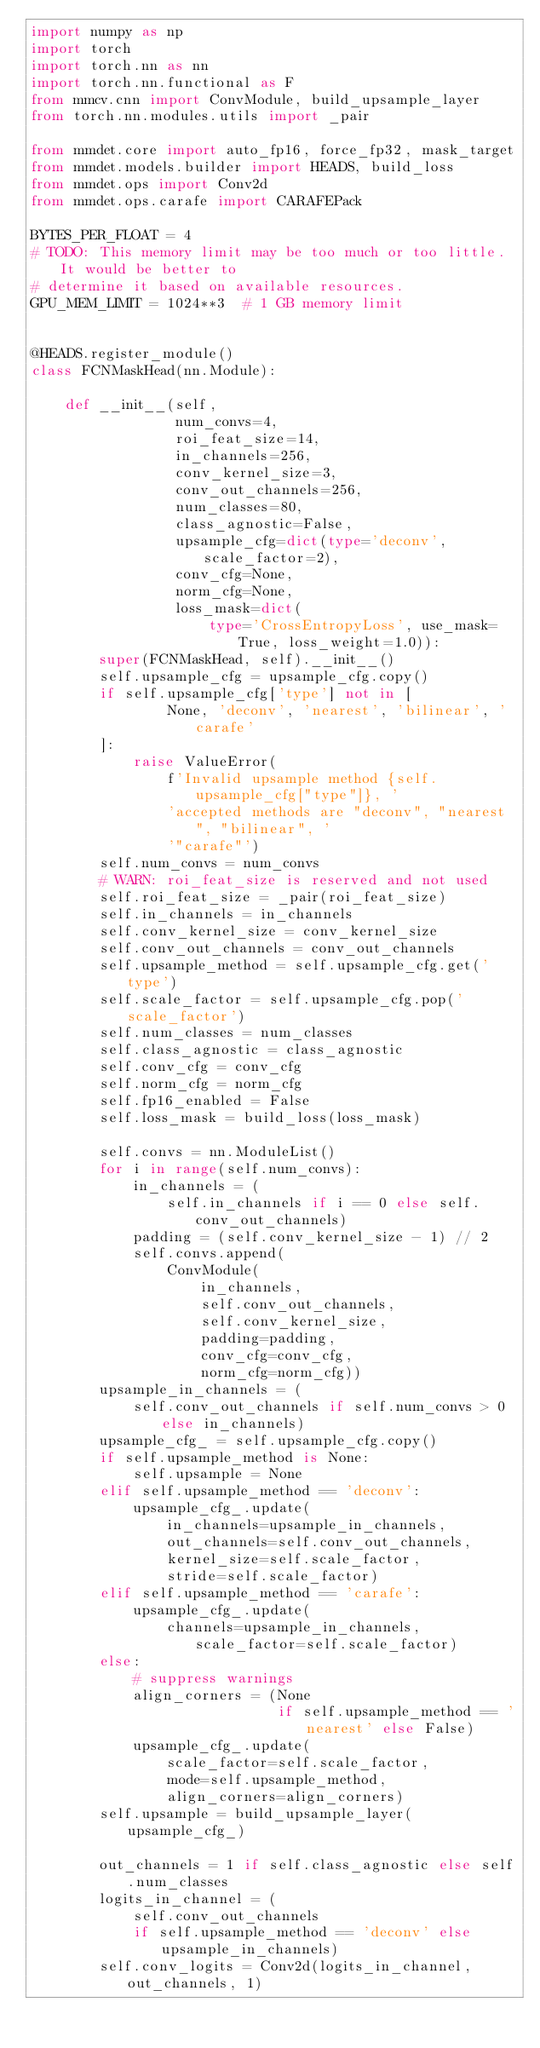Convert code to text. <code><loc_0><loc_0><loc_500><loc_500><_Python_>import numpy as np
import torch
import torch.nn as nn
import torch.nn.functional as F
from mmcv.cnn import ConvModule, build_upsample_layer
from torch.nn.modules.utils import _pair

from mmdet.core import auto_fp16, force_fp32, mask_target
from mmdet.models.builder import HEADS, build_loss
from mmdet.ops import Conv2d
from mmdet.ops.carafe import CARAFEPack

BYTES_PER_FLOAT = 4
# TODO: This memory limit may be too much or too little. It would be better to
# determine it based on available resources.
GPU_MEM_LIMIT = 1024**3  # 1 GB memory limit


@HEADS.register_module()
class FCNMaskHead(nn.Module):

    def __init__(self,
                 num_convs=4,
                 roi_feat_size=14,
                 in_channels=256,
                 conv_kernel_size=3,
                 conv_out_channels=256,
                 num_classes=80,
                 class_agnostic=False,
                 upsample_cfg=dict(type='deconv', scale_factor=2),
                 conv_cfg=None,
                 norm_cfg=None,
                 loss_mask=dict(
                     type='CrossEntropyLoss', use_mask=True, loss_weight=1.0)):
        super(FCNMaskHead, self).__init__()
        self.upsample_cfg = upsample_cfg.copy()
        if self.upsample_cfg['type'] not in [
                None, 'deconv', 'nearest', 'bilinear', 'carafe'
        ]:
            raise ValueError(
                f'Invalid upsample method {self.upsample_cfg["type"]}, '
                'accepted methods are "deconv", "nearest", "bilinear", '
                '"carafe"')
        self.num_convs = num_convs
        # WARN: roi_feat_size is reserved and not used
        self.roi_feat_size = _pair(roi_feat_size)
        self.in_channels = in_channels
        self.conv_kernel_size = conv_kernel_size
        self.conv_out_channels = conv_out_channels
        self.upsample_method = self.upsample_cfg.get('type')
        self.scale_factor = self.upsample_cfg.pop('scale_factor')
        self.num_classes = num_classes
        self.class_agnostic = class_agnostic
        self.conv_cfg = conv_cfg
        self.norm_cfg = norm_cfg
        self.fp16_enabled = False
        self.loss_mask = build_loss(loss_mask)

        self.convs = nn.ModuleList()
        for i in range(self.num_convs):
            in_channels = (
                self.in_channels if i == 0 else self.conv_out_channels)
            padding = (self.conv_kernel_size - 1) // 2
            self.convs.append(
                ConvModule(
                    in_channels,
                    self.conv_out_channels,
                    self.conv_kernel_size,
                    padding=padding,
                    conv_cfg=conv_cfg,
                    norm_cfg=norm_cfg))
        upsample_in_channels = (
            self.conv_out_channels if self.num_convs > 0 else in_channels)
        upsample_cfg_ = self.upsample_cfg.copy()
        if self.upsample_method is None:
            self.upsample = None
        elif self.upsample_method == 'deconv':
            upsample_cfg_.update(
                in_channels=upsample_in_channels,
                out_channels=self.conv_out_channels,
                kernel_size=self.scale_factor,
                stride=self.scale_factor)
        elif self.upsample_method == 'carafe':
            upsample_cfg_.update(
                channels=upsample_in_channels, scale_factor=self.scale_factor)
        else:
            # suppress warnings
            align_corners = (None
                             if self.upsample_method == 'nearest' else False)
            upsample_cfg_.update(
                scale_factor=self.scale_factor,
                mode=self.upsample_method,
                align_corners=align_corners)
        self.upsample = build_upsample_layer(upsample_cfg_)

        out_channels = 1 if self.class_agnostic else self.num_classes
        logits_in_channel = (
            self.conv_out_channels
            if self.upsample_method == 'deconv' else upsample_in_channels)
        self.conv_logits = Conv2d(logits_in_channel, out_channels, 1)</code> 